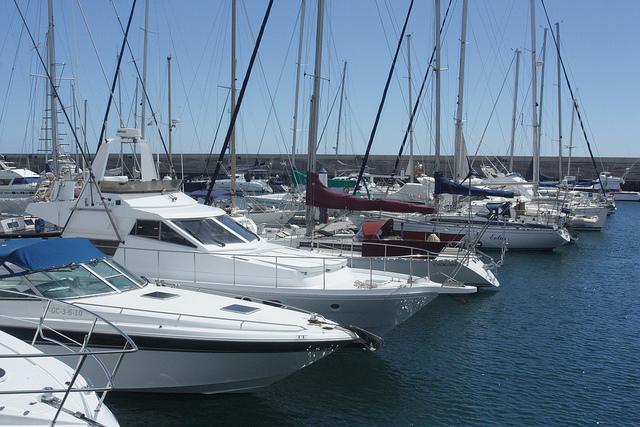Are any of these boats powered by gas engines?
Give a very brief answer. Yes. Why are all these boats parked here?
Be succinct. For docking. Is the water wavy?
Answer briefly. No. 